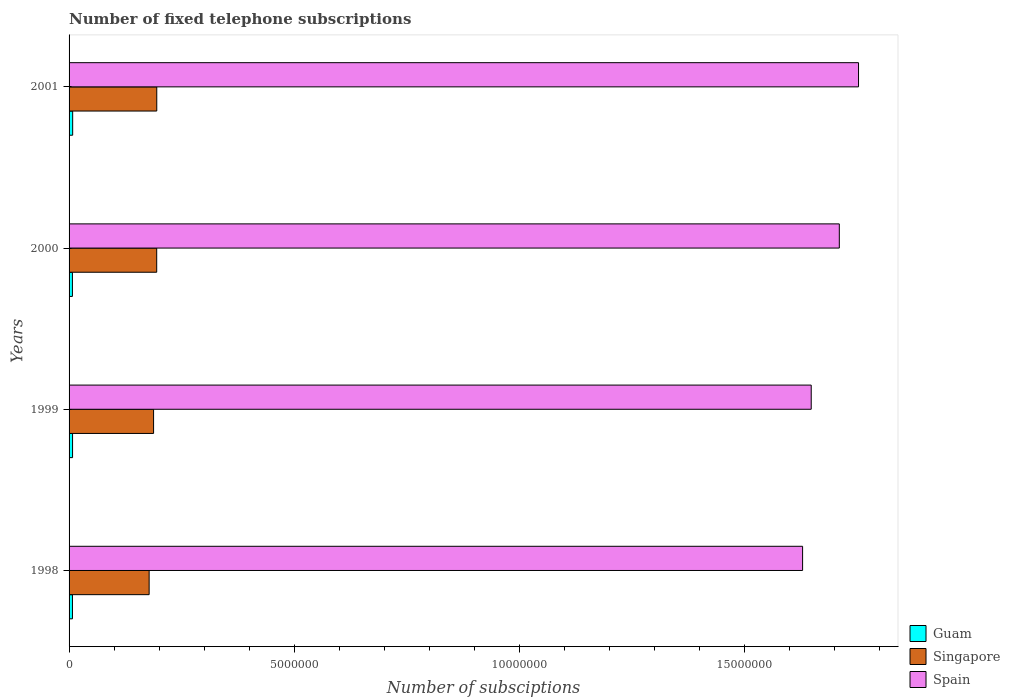Are the number of bars per tick equal to the number of legend labels?
Your answer should be very brief. Yes. In how many cases, is the number of bars for a given year not equal to the number of legend labels?
Ensure brevity in your answer.  0. What is the number of fixed telephone subscriptions in Singapore in 1999?
Offer a very short reply. 1.88e+06. Across all years, what is the maximum number of fixed telephone subscriptions in Singapore?
Your answer should be very brief. 1.95e+06. Across all years, what is the minimum number of fixed telephone subscriptions in Singapore?
Your response must be concise. 1.78e+06. In which year was the number of fixed telephone subscriptions in Singapore minimum?
Your answer should be compact. 1998. What is the total number of fixed telephone subscriptions in Singapore in the graph?
Provide a succinct answer. 7.55e+06. What is the difference between the number of fixed telephone subscriptions in Singapore in 1998 and that in 1999?
Offer a terse response. -9.87e+04. What is the difference between the number of fixed telephone subscriptions in Singapore in 2000 and the number of fixed telephone subscriptions in Spain in 2001?
Ensure brevity in your answer.  -1.56e+07. What is the average number of fixed telephone subscriptions in Guam per year?
Keep it short and to the point. 7.68e+04. In the year 2000, what is the difference between the number of fixed telephone subscriptions in Spain and number of fixed telephone subscriptions in Guam?
Provide a short and direct response. 1.70e+07. What is the ratio of the number of fixed telephone subscriptions in Guam in 1999 to that in 2000?
Provide a short and direct response. 1.04. What is the difference between the highest and the second highest number of fixed telephone subscriptions in Guam?
Provide a short and direct response. 2391. What is the difference between the highest and the lowest number of fixed telephone subscriptions in Singapore?
Offer a very short reply. 1.70e+05. In how many years, is the number of fixed telephone subscriptions in Spain greater than the average number of fixed telephone subscriptions in Spain taken over all years?
Provide a succinct answer. 2. What does the 3rd bar from the top in 1999 represents?
Make the answer very short. Guam. What does the 1st bar from the bottom in 2001 represents?
Offer a terse response. Guam. How many years are there in the graph?
Your answer should be very brief. 4. Does the graph contain grids?
Make the answer very short. No. How are the legend labels stacked?
Your answer should be very brief. Vertical. What is the title of the graph?
Offer a very short reply. Number of fixed telephone subscriptions. What is the label or title of the X-axis?
Make the answer very short. Number of subsciptions. What is the Number of subsciptions in Guam in 1998?
Your answer should be compact. 7.51e+04. What is the Number of subsciptions of Singapore in 1998?
Offer a very short reply. 1.78e+06. What is the Number of subsciptions of Spain in 1998?
Offer a terse response. 1.63e+07. What is the Number of subsciptions in Guam in 1999?
Your response must be concise. 7.76e+04. What is the Number of subsciptions in Singapore in 1999?
Offer a very short reply. 1.88e+06. What is the Number of subsciptions of Spain in 1999?
Provide a succinct answer. 1.65e+07. What is the Number of subsciptions in Guam in 2000?
Give a very brief answer. 7.44e+04. What is the Number of subsciptions in Singapore in 2000?
Your answer should be compact. 1.95e+06. What is the Number of subsciptions of Spain in 2000?
Offer a terse response. 1.71e+07. What is the Number of subsciptions of Guam in 2001?
Your response must be concise. 8.00e+04. What is the Number of subsciptions of Singapore in 2001?
Your answer should be very brief. 1.95e+06. What is the Number of subsciptions in Spain in 2001?
Provide a succinct answer. 1.75e+07. Across all years, what is the maximum Number of subsciptions of Singapore?
Offer a very short reply. 1.95e+06. Across all years, what is the maximum Number of subsciptions in Spain?
Keep it short and to the point. 1.75e+07. Across all years, what is the minimum Number of subsciptions of Guam?
Offer a terse response. 7.44e+04. Across all years, what is the minimum Number of subsciptions of Singapore?
Keep it short and to the point. 1.78e+06. Across all years, what is the minimum Number of subsciptions of Spain?
Make the answer very short. 1.63e+07. What is the total Number of subsciptions in Guam in the graph?
Offer a terse response. 3.07e+05. What is the total Number of subsciptions in Singapore in the graph?
Give a very brief answer. 7.55e+06. What is the total Number of subsciptions of Spain in the graph?
Your response must be concise. 6.74e+07. What is the difference between the Number of subsciptions in Guam in 1998 and that in 1999?
Offer a terse response. -2558. What is the difference between the Number of subsciptions in Singapore in 1998 and that in 1999?
Give a very brief answer. -9.87e+04. What is the difference between the Number of subsciptions of Spain in 1998 and that in 1999?
Make the answer very short. -1.92e+05. What is the difference between the Number of subsciptions in Guam in 1998 and that in 2000?
Keep it short and to the point. 684. What is the difference between the Number of subsciptions in Singapore in 1998 and that in 2000?
Keep it short and to the point. -1.68e+05. What is the difference between the Number of subsciptions in Spain in 1998 and that in 2000?
Give a very brief answer. -8.15e+05. What is the difference between the Number of subsciptions in Guam in 1998 and that in 2001?
Your answer should be compact. -4949. What is the difference between the Number of subsciptions in Singapore in 1998 and that in 2001?
Give a very brief answer. -1.70e+05. What is the difference between the Number of subsciptions of Spain in 1998 and that in 2001?
Give a very brief answer. -1.24e+06. What is the difference between the Number of subsciptions of Guam in 1999 and that in 2000?
Provide a short and direct response. 3242. What is the difference between the Number of subsciptions of Singapore in 1999 and that in 2000?
Make the answer very short. -6.94e+04. What is the difference between the Number of subsciptions of Spain in 1999 and that in 2000?
Keep it short and to the point. -6.24e+05. What is the difference between the Number of subsciptions in Guam in 1999 and that in 2001?
Offer a terse response. -2391. What is the difference between the Number of subsciptions in Singapore in 1999 and that in 2001?
Your answer should be very brief. -7.09e+04. What is the difference between the Number of subsciptions of Spain in 1999 and that in 2001?
Your answer should be compact. -1.05e+06. What is the difference between the Number of subsciptions in Guam in 2000 and that in 2001?
Offer a very short reply. -5633. What is the difference between the Number of subsciptions of Singapore in 2000 and that in 2001?
Make the answer very short. -1500. What is the difference between the Number of subsciptions of Spain in 2000 and that in 2001?
Your answer should be compact. -4.27e+05. What is the difference between the Number of subsciptions in Guam in 1998 and the Number of subsciptions in Singapore in 1999?
Offer a very short reply. -1.80e+06. What is the difference between the Number of subsciptions in Guam in 1998 and the Number of subsciptions in Spain in 1999?
Give a very brief answer. -1.64e+07. What is the difference between the Number of subsciptions of Singapore in 1998 and the Number of subsciptions of Spain in 1999?
Keep it short and to the point. -1.47e+07. What is the difference between the Number of subsciptions of Guam in 1998 and the Number of subsciptions of Singapore in 2000?
Provide a short and direct response. -1.87e+06. What is the difference between the Number of subsciptions in Guam in 1998 and the Number of subsciptions in Spain in 2000?
Offer a very short reply. -1.70e+07. What is the difference between the Number of subsciptions in Singapore in 1998 and the Number of subsciptions in Spain in 2000?
Give a very brief answer. -1.53e+07. What is the difference between the Number of subsciptions in Guam in 1998 and the Number of subsciptions in Singapore in 2001?
Ensure brevity in your answer.  -1.87e+06. What is the difference between the Number of subsciptions of Guam in 1998 and the Number of subsciptions of Spain in 2001?
Provide a succinct answer. -1.75e+07. What is the difference between the Number of subsciptions in Singapore in 1998 and the Number of subsciptions in Spain in 2001?
Offer a very short reply. -1.58e+07. What is the difference between the Number of subsciptions of Guam in 1999 and the Number of subsciptions of Singapore in 2000?
Offer a terse response. -1.87e+06. What is the difference between the Number of subsciptions in Guam in 1999 and the Number of subsciptions in Spain in 2000?
Keep it short and to the point. -1.70e+07. What is the difference between the Number of subsciptions in Singapore in 1999 and the Number of subsciptions in Spain in 2000?
Ensure brevity in your answer.  -1.52e+07. What is the difference between the Number of subsciptions in Guam in 1999 and the Number of subsciptions in Singapore in 2001?
Your answer should be very brief. -1.87e+06. What is the difference between the Number of subsciptions in Guam in 1999 and the Number of subsciptions in Spain in 2001?
Keep it short and to the point. -1.75e+07. What is the difference between the Number of subsciptions of Singapore in 1999 and the Number of subsciptions of Spain in 2001?
Provide a short and direct response. -1.57e+07. What is the difference between the Number of subsciptions of Guam in 2000 and the Number of subsciptions of Singapore in 2001?
Your answer should be very brief. -1.87e+06. What is the difference between the Number of subsciptions in Guam in 2000 and the Number of subsciptions in Spain in 2001?
Make the answer very short. -1.75e+07. What is the difference between the Number of subsciptions of Singapore in 2000 and the Number of subsciptions of Spain in 2001?
Ensure brevity in your answer.  -1.56e+07. What is the average Number of subsciptions of Guam per year?
Make the answer very short. 7.68e+04. What is the average Number of subsciptions in Singapore per year?
Give a very brief answer. 1.89e+06. What is the average Number of subsciptions in Spain per year?
Your answer should be compact. 1.69e+07. In the year 1998, what is the difference between the Number of subsciptions of Guam and Number of subsciptions of Singapore?
Offer a very short reply. -1.70e+06. In the year 1998, what is the difference between the Number of subsciptions in Guam and Number of subsciptions in Spain?
Your response must be concise. -1.62e+07. In the year 1998, what is the difference between the Number of subsciptions of Singapore and Number of subsciptions of Spain?
Your answer should be very brief. -1.45e+07. In the year 1999, what is the difference between the Number of subsciptions in Guam and Number of subsciptions in Singapore?
Give a very brief answer. -1.80e+06. In the year 1999, what is the difference between the Number of subsciptions of Guam and Number of subsciptions of Spain?
Your response must be concise. -1.64e+07. In the year 1999, what is the difference between the Number of subsciptions in Singapore and Number of subsciptions in Spain?
Give a very brief answer. -1.46e+07. In the year 2000, what is the difference between the Number of subsciptions in Guam and Number of subsciptions in Singapore?
Give a very brief answer. -1.87e+06. In the year 2000, what is the difference between the Number of subsciptions of Guam and Number of subsciptions of Spain?
Keep it short and to the point. -1.70e+07. In the year 2000, what is the difference between the Number of subsciptions in Singapore and Number of subsciptions in Spain?
Keep it short and to the point. -1.52e+07. In the year 2001, what is the difference between the Number of subsciptions in Guam and Number of subsciptions in Singapore?
Your answer should be very brief. -1.87e+06. In the year 2001, what is the difference between the Number of subsciptions in Guam and Number of subsciptions in Spain?
Offer a terse response. -1.75e+07. In the year 2001, what is the difference between the Number of subsciptions of Singapore and Number of subsciptions of Spain?
Your answer should be very brief. -1.56e+07. What is the ratio of the Number of subsciptions of Spain in 1998 to that in 1999?
Provide a succinct answer. 0.99. What is the ratio of the Number of subsciptions in Guam in 1998 to that in 2000?
Offer a very short reply. 1.01. What is the ratio of the Number of subsciptions in Singapore in 1998 to that in 2000?
Ensure brevity in your answer.  0.91. What is the ratio of the Number of subsciptions in Spain in 1998 to that in 2000?
Offer a terse response. 0.95. What is the ratio of the Number of subsciptions in Guam in 1998 to that in 2001?
Offer a very short reply. 0.94. What is the ratio of the Number of subsciptions of Singapore in 1998 to that in 2001?
Offer a terse response. 0.91. What is the ratio of the Number of subsciptions in Spain in 1998 to that in 2001?
Your response must be concise. 0.93. What is the ratio of the Number of subsciptions in Guam in 1999 to that in 2000?
Ensure brevity in your answer.  1.04. What is the ratio of the Number of subsciptions in Singapore in 1999 to that in 2000?
Your response must be concise. 0.96. What is the ratio of the Number of subsciptions in Spain in 1999 to that in 2000?
Provide a succinct answer. 0.96. What is the ratio of the Number of subsciptions of Guam in 1999 to that in 2001?
Offer a very short reply. 0.97. What is the ratio of the Number of subsciptions of Singapore in 1999 to that in 2001?
Your answer should be compact. 0.96. What is the ratio of the Number of subsciptions of Spain in 1999 to that in 2001?
Your response must be concise. 0.94. What is the ratio of the Number of subsciptions in Guam in 2000 to that in 2001?
Keep it short and to the point. 0.93. What is the ratio of the Number of subsciptions of Singapore in 2000 to that in 2001?
Your answer should be compact. 1. What is the ratio of the Number of subsciptions of Spain in 2000 to that in 2001?
Offer a terse response. 0.98. What is the difference between the highest and the second highest Number of subsciptions in Guam?
Provide a succinct answer. 2391. What is the difference between the highest and the second highest Number of subsciptions of Singapore?
Provide a succinct answer. 1500. What is the difference between the highest and the second highest Number of subsciptions of Spain?
Offer a terse response. 4.27e+05. What is the difference between the highest and the lowest Number of subsciptions in Guam?
Make the answer very short. 5633. What is the difference between the highest and the lowest Number of subsciptions of Singapore?
Give a very brief answer. 1.70e+05. What is the difference between the highest and the lowest Number of subsciptions of Spain?
Ensure brevity in your answer.  1.24e+06. 